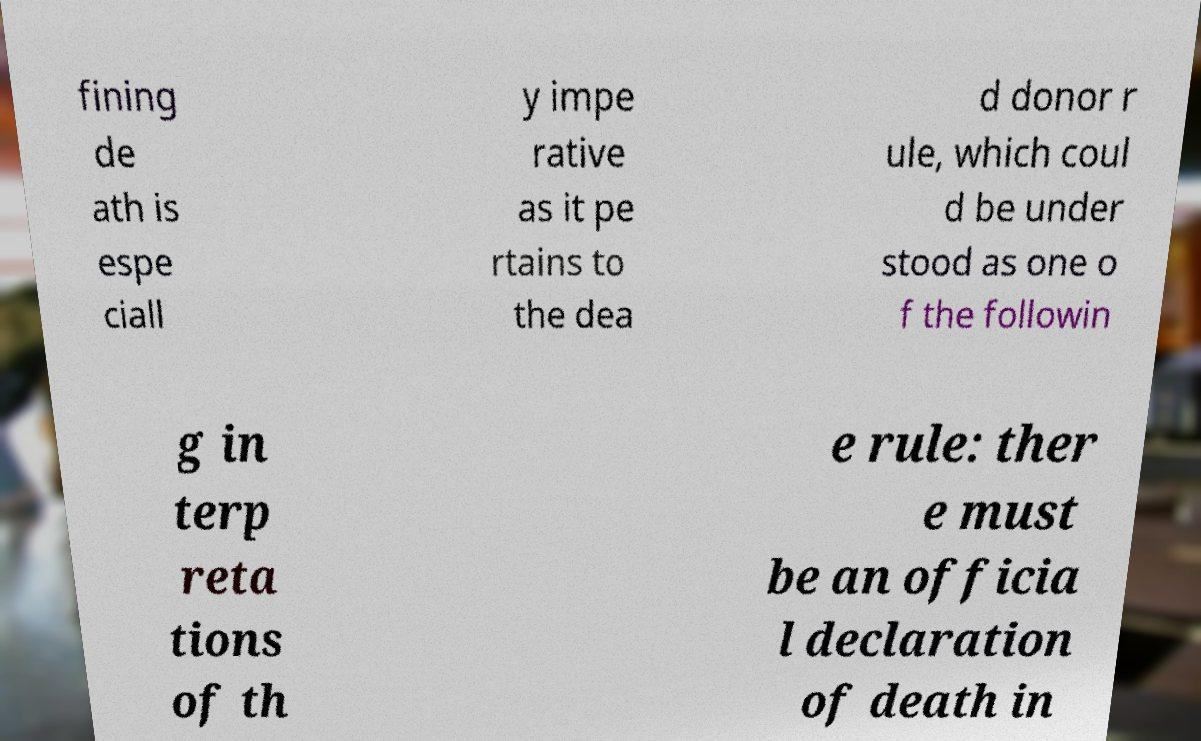Can you accurately transcribe the text from the provided image for me? fining de ath is espe ciall y impe rative as it pe rtains to the dea d donor r ule, which coul d be under stood as one o f the followin g in terp reta tions of th e rule: ther e must be an officia l declaration of death in 